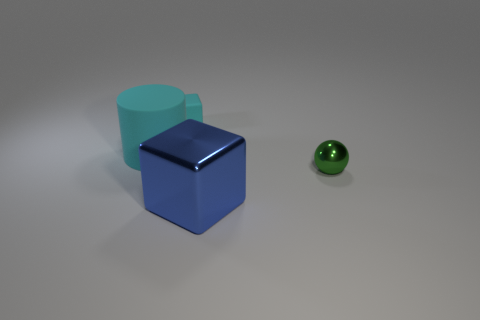Is there a thing made of the same material as the big blue cube?
Keep it short and to the point. Yes. What is the color of the rubber thing that is the same shape as the blue metallic object?
Make the answer very short. Cyan. Do the cyan cylinder and the cyan thing behind the cyan cylinder have the same material?
Your answer should be very brief. Yes. The cyan object that is to the left of the tiny object to the left of the small green sphere is what shape?
Your answer should be compact. Cylinder. Is the size of the cyan matte thing right of the cyan rubber cylinder the same as the cyan rubber cylinder?
Ensure brevity in your answer.  No. How many other objects are there of the same shape as the big blue metal object?
Offer a very short reply. 1. Is the color of the rubber thing in front of the small rubber cube the same as the tiny ball?
Offer a terse response. No. Are there any matte cubes of the same color as the small rubber object?
Provide a succinct answer. No. How many green metal objects are in front of the large cyan rubber thing?
Provide a short and direct response. 1. What number of other objects are there of the same size as the green metallic thing?
Your answer should be compact. 1. 